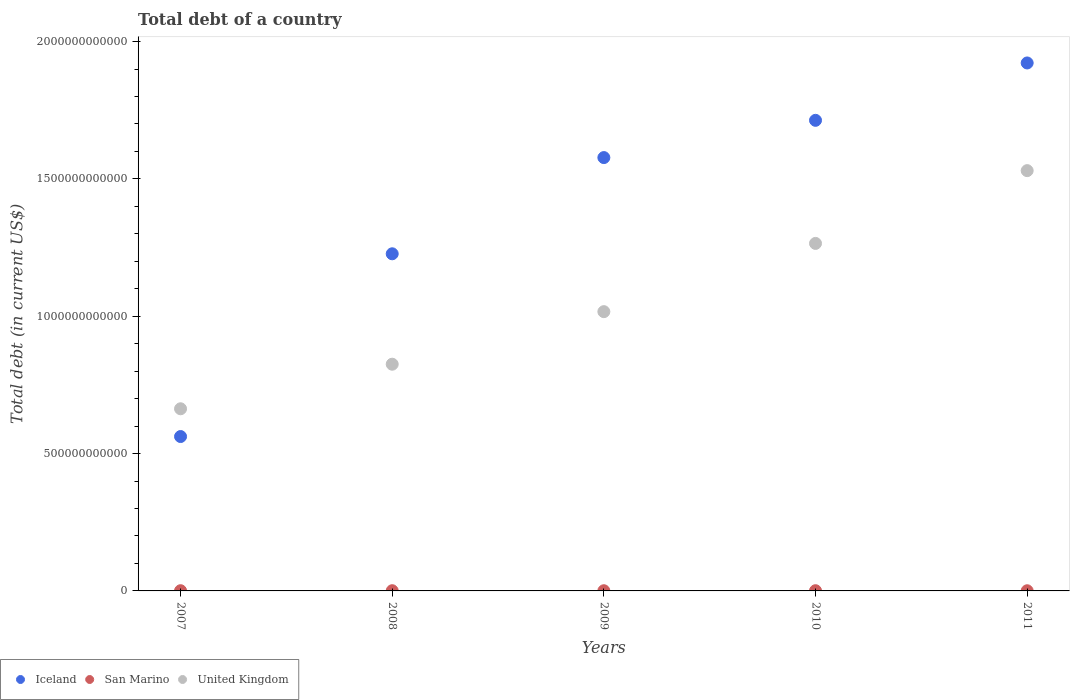Is the number of dotlines equal to the number of legend labels?
Offer a very short reply. Yes. What is the debt in San Marino in 2007?
Give a very brief answer. 7.58e+08. Across all years, what is the maximum debt in United Kingdom?
Your answer should be very brief. 1.53e+12. Across all years, what is the minimum debt in San Marino?
Provide a succinct answer. 5.84e+08. In which year was the debt in United Kingdom maximum?
Your answer should be very brief. 2011. In which year was the debt in United Kingdom minimum?
Make the answer very short. 2007. What is the total debt in United Kingdom in the graph?
Offer a very short reply. 5.30e+12. What is the difference between the debt in United Kingdom in 2007 and that in 2011?
Ensure brevity in your answer.  -8.67e+11. What is the difference between the debt in United Kingdom in 2009 and the debt in Iceland in 2007?
Your answer should be compact. 4.55e+11. What is the average debt in Iceland per year?
Make the answer very short. 1.40e+12. In the year 2011, what is the difference between the debt in San Marino and debt in Iceland?
Offer a terse response. -1.92e+12. What is the ratio of the debt in San Marino in 2007 to that in 2011?
Provide a short and direct response. 1.3. What is the difference between the highest and the second highest debt in United Kingdom?
Offer a terse response. 2.65e+11. What is the difference between the highest and the lowest debt in Iceland?
Make the answer very short. 1.36e+12. Is the sum of the debt in Iceland in 2007 and 2010 greater than the maximum debt in United Kingdom across all years?
Keep it short and to the point. Yes. Is it the case that in every year, the sum of the debt in San Marino and debt in United Kingdom  is greater than the debt in Iceland?
Your response must be concise. No. Is the debt in San Marino strictly less than the debt in United Kingdom over the years?
Ensure brevity in your answer.  Yes. How many years are there in the graph?
Your response must be concise. 5. What is the difference between two consecutive major ticks on the Y-axis?
Offer a very short reply. 5.00e+11. Are the values on the major ticks of Y-axis written in scientific E-notation?
Your answer should be very brief. No. Does the graph contain grids?
Offer a very short reply. No. What is the title of the graph?
Your answer should be very brief. Total debt of a country. Does "Hong Kong" appear as one of the legend labels in the graph?
Your response must be concise. No. What is the label or title of the X-axis?
Provide a succinct answer. Years. What is the label or title of the Y-axis?
Offer a terse response. Total debt (in current US$). What is the Total debt (in current US$) in Iceland in 2007?
Your answer should be very brief. 5.62e+11. What is the Total debt (in current US$) of San Marino in 2007?
Your answer should be very brief. 7.58e+08. What is the Total debt (in current US$) in United Kingdom in 2007?
Keep it short and to the point. 6.63e+11. What is the Total debt (in current US$) in Iceland in 2008?
Make the answer very short. 1.23e+12. What is the Total debt (in current US$) in San Marino in 2008?
Offer a very short reply. 7.66e+08. What is the Total debt (in current US$) of United Kingdom in 2008?
Keep it short and to the point. 8.25e+11. What is the Total debt (in current US$) of Iceland in 2009?
Keep it short and to the point. 1.58e+12. What is the Total debt (in current US$) in San Marino in 2009?
Your answer should be compact. 6.90e+08. What is the Total debt (in current US$) of United Kingdom in 2009?
Give a very brief answer. 1.02e+12. What is the Total debt (in current US$) of Iceland in 2010?
Give a very brief answer. 1.71e+12. What is the Total debt (in current US$) of San Marino in 2010?
Your response must be concise. 7.80e+08. What is the Total debt (in current US$) in United Kingdom in 2010?
Provide a succinct answer. 1.27e+12. What is the Total debt (in current US$) of Iceland in 2011?
Make the answer very short. 1.92e+12. What is the Total debt (in current US$) of San Marino in 2011?
Make the answer very short. 5.84e+08. What is the Total debt (in current US$) in United Kingdom in 2011?
Your answer should be very brief. 1.53e+12. Across all years, what is the maximum Total debt (in current US$) of Iceland?
Make the answer very short. 1.92e+12. Across all years, what is the maximum Total debt (in current US$) in San Marino?
Make the answer very short. 7.80e+08. Across all years, what is the maximum Total debt (in current US$) of United Kingdom?
Your answer should be compact. 1.53e+12. Across all years, what is the minimum Total debt (in current US$) of Iceland?
Make the answer very short. 5.62e+11. Across all years, what is the minimum Total debt (in current US$) of San Marino?
Offer a terse response. 5.84e+08. Across all years, what is the minimum Total debt (in current US$) in United Kingdom?
Offer a very short reply. 6.63e+11. What is the total Total debt (in current US$) of Iceland in the graph?
Give a very brief answer. 7.00e+12. What is the total Total debt (in current US$) of San Marino in the graph?
Make the answer very short. 3.58e+09. What is the total Total debt (in current US$) in United Kingdom in the graph?
Offer a terse response. 5.30e+12. What is the difference between the Total debt (in current US$) of Iceland in 2007 and that in 2008?
Offer a very short reply. -6.65e+11. What is the difference between the Total debt (in current US$) in San Marino in 2007 and that in 2008?
Give a very brief answer. -8.04e+06. What is the difference between the Total debt (in current US$) of United Kingdom in 2007 and that in 2008?
Your answer should be compact. -1.62e+11. What is the difference between the Total debt (in current US$) of Iceland in 2007 and that in 2009?
Offer a very short reply. -1.02e+12. What is the difference between the Total debt (in current US$) of San Marino in 2007 and that in 2009?
Your response must be concise. 6.80e+07. What is the difference between the Total debt (in current US$) in United Kingdom in 2007 and that in 2009?
Make the answer very short. -3.54e+11. What is the difference between the Total debt (in current US$) in Iceland in 2007 and that in 2010?
Offer a very short reply. -1.15e+12. What is the difference between the Total debt (in current US$) in San Marino in 2007 and that in 2010?
Give a very brief answer. -2.23e+07. What is the difference between the Total debt (in current US$) of United Kingdom in 2007 and that in 2010?
Your response must be concise. -6.02e+11. What is the difference between the Total debt (in current US$) of Iceland in 2007 and that in 2011?
Offer a very short reply. -1.36e+12. What is the difference between the Total debt (in current US$) of San Marino in 2007 and that in 2011?
Your answer should be compact. 1.74e+08. What is the difference between the Total debt (in current US$) of United Kingdom in 2007 and that in 2011?
Your answer should be very brief. -8.67e+11. What is the difference between the Total debt (in current US$) of Iceland in 2008 and that in 2009?
Keep it short and to the point. -3.50e+11. What is the difference between the Total debt (in current US$) of San Marino in 2008 and that in 2009?
Provide a short and direct response. 7.60e+07. What is the difference between the Total debt (in current US$) of United Kingdom in 2008 and that in 2009?
Provide a succinct answer. -1.91e+11. What is the difference between the Total debt (in current US$) of Iceland in 2008 and that in 2010?
Your response must be concise. -4.86e+11. What is the difference between the Total debt (in current US$) of San Marino in 2008 and that in 2010?
Ensure brevity in your answer.  -1.42e+07. What is the difference between the Total debt (in current US$) in United Kingdom in 2008 and that in 2010?
Your answer should be compact. -4.40e+11. What is the difference between the Total debt (in current US$) of Iceland in 2008 and that in 2011?
Keep it short and to the point. -6.95e+11. What is the difference between the Total debt (in current US$) of San Marino in 2008 and that in 2011?
Your response must be concise. 1.82e+08. What is the difference between the Total debt (in current US$) of United Kingdom in 2008 and that in 2011?
Offer a terse response. -7.05e+11. What is the difference between the Total debt (in current US$) of Iceland in 2009 and that in 2010?
Make the answer very short. -1.36e+11. What is the difference between the Total debt (in current US$) of San Marino in 2009 and that in 2010?
Your answer should be very brief. -9.03e+07. What is the difference between the Total debt (in current US$) in United Kingdom in 2009 and that in 2010?
Your answer should be very brief. -2.48e+11. What is the difference between the Total debt (in current US$) in Iceland in 2009 and that in 2011?
Offer a terse response. -3.44e+11. What is the difference between the Total debt (in current US$) in San Marino in 2009 and that in 2011?
Ensure brevity in your answer.  1.06e+08. What is the difference between the Total debt (in current US$) in United Kingdom in 2009 and that in 2011?
Provide a short and direct response. -5.13e+11. What is the difference between the Total debt (in current US$) of Iceland in 2010 and that in 2011?
Provide a succinct answer. -2.09e+11. What is the difference between the Total debt (in current US$) of San Marino in 2010 and that in 2011?
Your response must be concise. 1.96e+08. What is the difference between the Total debt (in current US$) of United Kingdom in 2010 and that in 2011?
Provide a succinct answer. -2.65e+11. What is the difference between the Total debt (in current US$) in Iceland in 2007 and the Total debt (in current US$) in San Marino in 2008?
Provide a short and direct response. 5.61e+11. What is the difference between the Total debt (in current US$) of Iceland in 2007 and the Total debt (in current US$) of United Kingdom in 2008?
Provide a succinct answer. -2.63e+11. What is the difference between the Total debt (in current US$) in San Marino in 2007 and the Total debt (in current US$) in United Kingdom in 2008?
Make the answer very short. -8.25e+11. What is the difference between the Total debt (in current US$) of Iceland in 2007 and the Total debt (in current US$) of San Marino in 2009?
Ensure brevity in your answer.  5.61e+11. What is the difference between the Total debt (in current US$) in Iceland in 2007 and the Total debt (in current US$) in United Kingdom in 2009?
Your response must be concise. -4.55e+11. What is the difference between the Total debt (in current US$) of San Marino in 2007 and the Total debt (in current US$) of United Kingdom in 2009?
Provide a short and direct response. -1.02e+12. What is the difference between the Total debt (in current US$) in Iceland in 2007 and the Total debt (in current US$) in San Marino in 2010?
Offer a terse response. 5.61e+11. What is the difference between the Total debt (in current US$) in Iceland in 2007 and the Total debt (in current US$) in United Kingdom in 2010?
Provide a succinct answer. -7.03e+11. What is the difference between the Total debt (in current US$) of San Marino in 2007 and the Total debt (in current US$) of United Kingdom in 2010?
Your answer should be very brief. -1.26e+12. What is the difference between the Total debt (in current US$) in Iceland in 2007 and the Total debt (in current US$) in San Marino in 2011?
Offer a very short reply. 5.61e+11. What is the difference between the Total debt (in current US$) of Iceland in 2007 and the Total debt (in current US$) of United Kingdom in 2011?
Give a very brief answer. -9.68e+11. What is the difference between the Total debt (in current US$) of San Marino in 2007 and the Total debt (in current US$) of United Kingdom in 2011?
Your response must be concise. -1.53e+12. What is the difference between the Total debt (in current US$) in Iceland in 2008 and the Total debt (in current US$) in San Marino in 2009?
Give a very brief answer. 1.23e+12. What is the difference between the Total debt (in current US$) of Iceland in 2008 and the Total debt (in current US$) of United Kingdom in 2009?
Offer a very short reply. 2.11e+11. What is the difference between the Total debt (in current US$) of San Marino in 2008 and the Total debt (in current US$) of United Kingdom in 2009?
Provide a short and direct response. -1.02e+12. What is the difference between the Total debt (in current US$) in Iceland in 2008 and the Total debt (in current US$) in San Marino in 2010?
Provide a short and direct response. 1.23e+12. What is the difference between the Total debt (in current US$) in Iceland in 2008 and the Total debt (in current US$) in United Kingdom in 2010?
Keep it short and to the point. -3.78e+1. What is the difference between the Total debt (in current US$) of San Marino in 2008 and the Total debt (in current US$) of United Kingdom in 2010?
Offer a very short reply. -1.26e+12. What is the difference between the Total debt (in current US$) of Iceland in 2008 and the Total debt (in current US$) of San Marino in 2011?
Your response must be concise. 1.23e+12. What is the difference between the Total debt (in current US$) of Iceland in 2008 and the Total debt (in current US$) of United Kingdom in 2011?
Offer a terse response. -3.03e+11. What is the difference between the Total debt (in current US$) in San Marino in 2008 and the Total debt (in current US$) in United Kingdom in 2011?
Offer a very short reply. -1.53e+12. What is the difference between the Total debt (in current US$) in Iceland in 2009 and the Total debt (in current US$) in San Marino in 2010?
Keep it short and to the point. 1.58e+12. What is the difference between the Total debt (in current US$) of Iceland in 2009 and the Total debt (in current US$) of United Kingdom in 2010?
Provide a succinct answer. 3.12e+11. What is the difference between the Total debt (in current US$) of San Marino in 2009 and the Total debt (in current US$) of United Kingdom in 2010?
Provide a short and direct response. -1.26e+12. What is the difference between the Total debt (in current US$) of Iceland in 2009 and the Total debt (in current US$) of San Marino in 2011?
Give a very brief answer. 1.58e+12. What is the difference between the Total debt (in current US$) of Iceland in 2009 and the Total debt (in current US$) of United Kingdom in 2011?
Your response must be concise. 4.75e+1. What is the difference between the Total debt (in current US$) of San Marino in 2009 and the Total debt (in current US$) of United Kingdom in 2011?
Offer a terse response. -1.53e+12. What is the difference between the Total debt (in current US$) in Iceland in 2010 and the Total debt (in current US$) in San Marino in 2011?
Provide a short and direct response. 1.71e+12. What is the difference between the Total debt (in current US$) in Iceland in 2010 and the Total debt (in current US$) in United Kingdom in 2011?
Ensure brevity in your answer.  1.83e+11. What is the difference between the Total debt (in current US$) of San Marino in 2010 and the Total debt (in current US$) of United Kingdom in 2011?
Give a very brief answer. -1.53e+12. What is the average Total debt (in current US$) of Iceland per year?
Provide a short and direct response. 1.40e+12. What is the average Total debt (in current US$) of San Marino per year?
Keep it short and to the point. 7.16e+08. What is the average Total debt (in current US$) in United Kingdom per year?
Provide a short and direct response. 1.06e+12. In the year 2007, what is the difference between the Total debt (in current US$) of Iceland and Total debt (in current US$) of San Marino?
Give a very brief answer. 5.61e+11. In the year 2007, what is the difference between the Total debt (in current US$) in Iceland and Total debt (in current US$) in United Kingdom?
Give a very brief answer. -1.01e+11. In the year 2007, what is the difference between the Total debt (in current US$) of San Marino and Total debt (in current US$) of United Kingdom?
Make the answer very short. -6.62e+11. In the year 2008, what is the difference between the Total debt (in current US$) of Iceland and Total debt (in current US$) of San Marino?
Your answer should be compact. 1.23e+12. In the year 2008, what is the difference between the Total debt (in current US$) in Iceland and Total debt (in current US$) in United Kingdom?
Offer a very short reply. 4.02e+11. In the year 2008, what is the difference between the Total debt (in current US$) of San Marino and Total debt (in current US$) of United Kingdom?
Provide a succinct answer. -8.25e+11. In the year 2009, what is the difference between the Total debt (in current US$) of Iceland and Total debt (in current US$) of San Marino?
Offer a terse response. 1.58e+12. In the year 2009, what is the difference between the Total debt (in current US$) in Iceland and Total debt (in current US$) in United Kingdom?
Provide a succinct answer. 5.61e+11. In the year 2009, what is the difference between the Total debt (in current US$) in San Marino and Total debt (in current US$) in United Kingdom?
Provide a succinct answer. -1.02e+12. In the year 2010, what is the difference between the Total debt (in current US$) of Iceland and Total debt (in current US$) of San Marino?
Keep it short and to the point. 1.71e+12. In the year 2010, what is the difference between the Total debt (in current US$) of Iceland and Total debt (in current US$) of United Kingdom?
Offer a terse response. 4.48e+11. In the year 2010, what is the difference between the Total debt (in current US$) of San Marino and Total debt (in current US$) of United Kingdom?
Your response must be concise. -1.26e+12. In the year 2011, what is the difference between the Total debt (in current US$) in Iceland and Total debt (in current US$) in San Marino?
Keep it short and to the point. 1.92e+12. In the year 2011, what is the difference between the Total debt (in current US$) of Iceland and Total debt (in current US$) of United Kingdom?
Offer a very short reply. 3.92e+11. In the year 2011, what is the difference between the Total debt (in current US$) of San Marino and Total debt (in current US$) of United Kingdom?
Keep it short and to the point. -1.53e+12. What is the ratio of the Total debt (in current US$) of Iceland in 2007 to that in 2008?
Give a very brief answer. 0.46. What is the ratio of the Total debt (in current US$) in San Marino in 2007 to that in 2008?
Give a very brief answer. 0.99. What is the ratio of the Total debt (in current US$) of United Kingdom in 2007 to that in 2008?
Ensure brevity in your answer.  0.8. What is the ratio of the Total debt (in current US$) in Iceland in 2007 to that in 2009?
Your answer should be very brief. 0.36. What is the ratio of the Total debt (in current US$) of San Marino in 2007 to that in 2009?
Give a very brief answer. 1.1. What is the ratio of the Total debt (in current US$) of United Kingdom in 2007 to that in 2009?
Your answer should be compact. 0.65. What is the ratio of the Total debt (in current US$) in Iceland in 2007 to that in 2010?
Make the answer very short. 0.33. What is the ratio of the Total debt (in current US$) of San Marino in 2007 to that in 2010?
Keep it short and to the point. 0.97. What is the ratio of the Total debt (in current US$) in United Kingdom in 2007 to that in 2010?
Ensure brevity in your answer.  0.52. What is the ratio of the Total debt (in current US$) in Iceland in 2007 to that in 2011?
Provide a short and direct response. 0.29. What is the ratio of the Total debt (in current US$) in San Marino in 2007 to that in 2011?
Keep it short and to the point. 1.3. What is the ratio of the Total debt (in current US$) in United Kingdom in 2007 to that in 2011?
Ensure brevity in your answer.  0.43. What is the ratio of the Total debt (in current US$) in Iceland in 2008 to that in 2009?
Make the answer very short. 0.78. What is the ratio of the Total debt (in current US$) of San Marino in 2008 to that in 2009?
Your response must be concise. 1.11. What is the ratio of the Total debt (in current US$) of United Kingdom in 2008 to that in 2009?
Keep it short and to the point. 0.81. What is the ratio of the Total debt (in current US$) of Iceland in 2008 to that in 2010?
Keep it short and to the point. 0.72. What is the ratio of the Total debt (in current US$) of San Marino in 2008 to that in 2010?
Make the answer very short. 0.98. What is the ratio of the Total debt (in current US$) in United Kingdom in 2008 to that in 2010?
Provide a succinct answer. 0.65. What is the ratio of the Total debt (in current US$) of Iceland in 2008 to that in 2011?
Keep it short and to the point. 0.64. What is the ratio of the Total debt (in current US$) of San Marino in 2008 to that in 2011?
Make the answer very short. 1.31. What is the ratio of the Total debt (in current US$) in United Kingdom in 2008 to that in 2011?
Your answer should be compact. 0.54. What is the ratio of the Total debt (in current US$) of Iceland in 2009 to that in 2010?
Offer a very short reply. 0.92. What is the ratio of the Total debt (in current US$) in San Marino in 2009 to that in 2010?
Your response must be concise. 0.88. What is the ratio of the Total debt (in current US$) of United Kingdom in 2009 to that in 2010?
Your response must be concise. 0.8. What is the ratio of the Total debt (in current US$) in Iceland in 2009 to that in 2011?
Provide a succinct answer. 0.82. What is the ratio of the Total debt (in current US$) in San Marino in 2009 to that in 2011?
Provide a short and direct response. 1.18. What is the ratio of the Total debt (in current US$) of United Kingdom in 2009 to that in 2011?
Your answer should be compact. 0.66. What is the ratio of the Total debt (in current US$) of Iceland in 2010 to that in 2011?
Offer a very short reply. 0.89. What is the ratio of the Total debt (in current US$) of San Marino in 2010 to that in 2011?
Offer a very short reply. 1.34. What is the ratio of the Total debt (in current US$) in United Kingdom in 2010 to that in 2011?
Ensure brevity in your answer.  0.83. What is the difference between the highest and the second highest Total debt (in current US$) in Iceland?
Provide a succinct answer. 2.09e+11. What is the difference between the highest and the second highest Total debt (in current US$) in San Marino?
Make the answer very short. 1.42e+07. What is the difference between the highest and the second highest Total debt (in current US$) in United Kingdom?
Make the answer very short. 2.65e+11. What is the difference between the highest and the lowest Total debt (in current US$) of Iceland?
Offer a very short reply. 1.36e+12. What is the difference between the highest and the lowest Total debt (in current US$) of San Marino?
Provide a short and direct response. 1.96e+08. What is the difference between the highest and the lowest Total debt (in current US$) of United Kingdom?
Provide a short and direct response. 8.67e+11. 